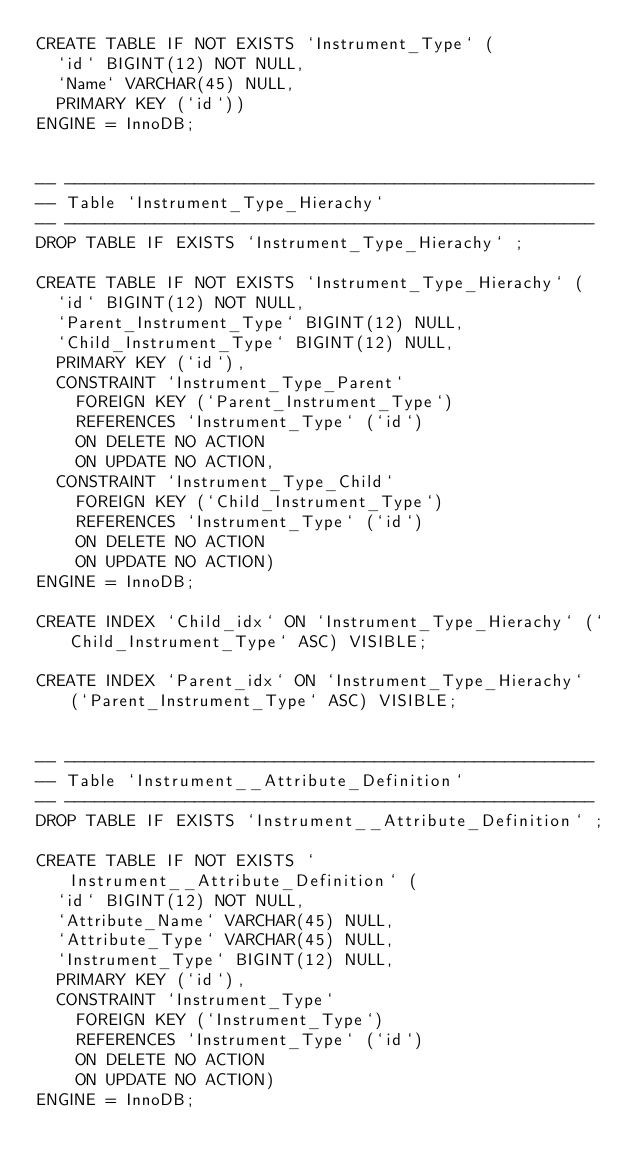Convert code to text. <code><loc_0><loc_0><loc_500><loc_500><_SQL_>CREATE TABLE IF NOT EXISTS `Instrument_Type` (
  `id` BIGINT(12) NOT NULL,
  `Name` VARCHAR(45) NULL,
  PRIMARY KEY (`id`))
ENGINE = InnoDB;


-- -----------------------------------------------------
-- Table `Instrument_Type_Hierachy`
-- -----------------------------------------------------
DROP TABLE IF EXISTS `Instrument_Type_Hierachy` ;

CREATE TABLE IF NOT EXISTS `Instrument_Type_Hierachy` (
  `id` BIGINT(12) NOT NULL,
  `Parent_Instrument_Type` BIGINT(12) NULL,
  `Child_Instrument_Type` BIGINT(12) NULL,
  PRIMARY KEY (`id`),
  CONSTRAINT `Instrument_Type_Parent`
    FOREIGN KEY (`Parent_Instrument_Type`)
    REFERENCES `Instrument_Type` (`id`)
    ON DELETE NO ACTION
    ON UPDATE NO ACTION,
  CONSTRAINT `Instrument_Type_Child`
    FOREIGN KEY (`Child_Instrument_Type`)
    REFERENCES `Instrument_Type` (`id`)
    ON DELETE NO ACTION
    ON UPDATE NO ACTION)
ENGINE = InnoDB;

CREATE INDEX `Child_idx` ON `Instrument_Type_Hierachy` (`Child_Instrument_Type` ASC) VISIBLE;

CREATE INDEX `Parent_idx` ON `Instrument_Type_Hierachy` (`Parent_Instrument_Type` ASC) VISIBLE;


-- -----------------------------------------------------
-- Table `Instrument__Attribute_Definition`
-- -----------------------------------------------------
DROP TABLE IF EXISTS `Instrument__Attribute_Definition` ;

CREATE TABLE IF NOT EXISTS `Instrument__Attribute_Definition` (
  `id` BIGINT(12) NOT NULL,
  `Attribute_Name` VARCHAR(45) NULL,
  `Attribute_Type` VARCHAR(45) NULL,
  `Instrument_Type` BIGINT(12) NULL,
  PRIMARY KEY (`id`),
  CONSTRAINT `Instrument_Type`
    FOREIGN KEY (`Instrument_Type`)
    REFERENCES `Instrument_Type` (`id`)
    ON DELETE NO ACTION
    ON UPDATE NO ACTION)
ENGINE = InnoDB;
</code> 